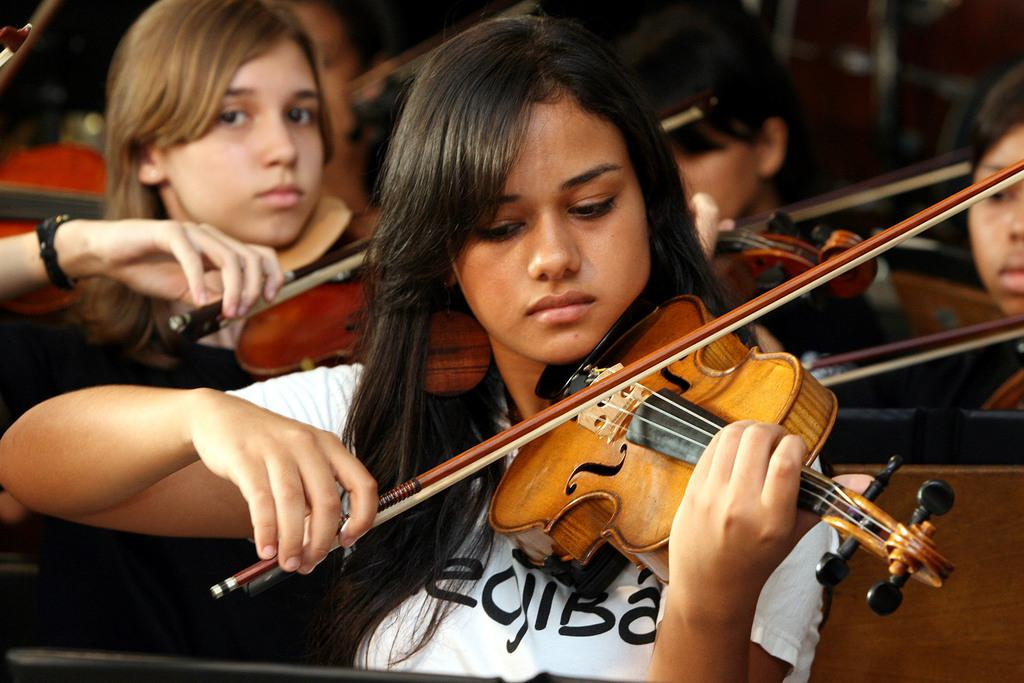Who or what can be seen in the image? There are people in the image. What are the people doing in the image? The people are playing violins. How does the door affect the acoustics of the violin performance in the image? There is no door present in the image, so its effect on the acoustics cannot be determined. 